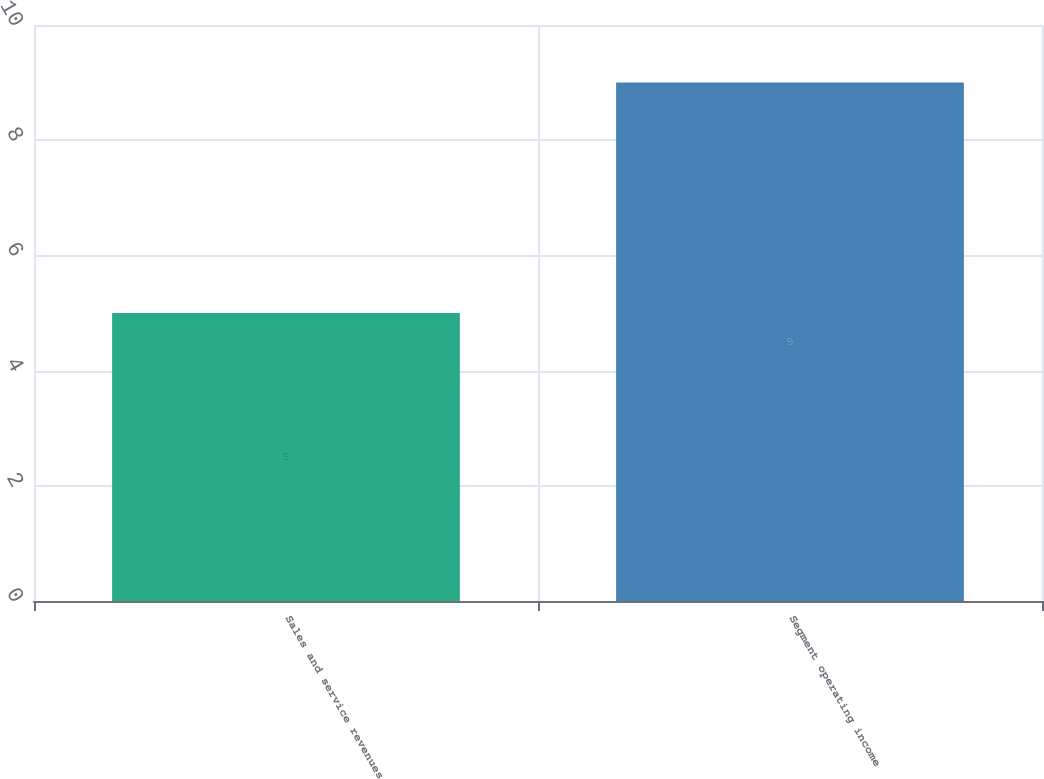<chart> <loc_0><loc_0><loc_500><loc_500><bar_chart><fcel>Sales and service revenues<fcel>Segment operating income<nl><fcel>5<fcel>9<nl></chart> 